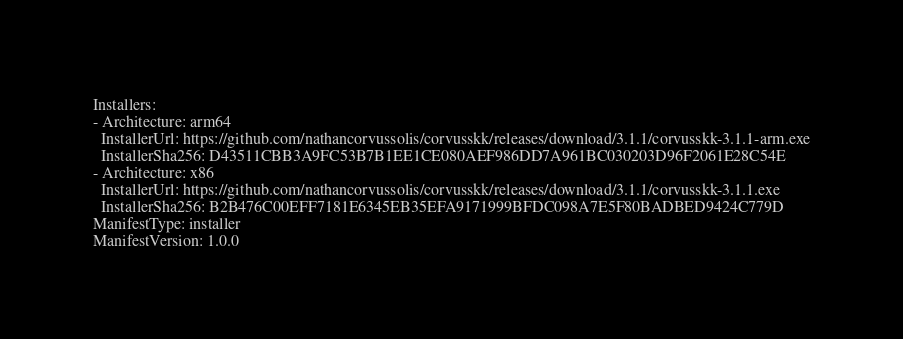Convert code to text. <code><loc_0><loc_0><loc_500><loc_500><_YAML_>Installers:
- Architecture: arm64
  InstallerUrl: https://github.com/nathancorvussolis/corvusskk/releases/download/3.1.1/corvusskk-3.1.1-arm.exe
  InstallerSha256: D43511CBB3A9FC53B7B1EE1CE080AEF986DD7A961BC030203D96F2061E28C54E
- Architecture: x86
  InstallerUrl: https://github.com/nathancorvussolis/corvusskk/releases/download/3.1.1/corvusskk-3.1.1.exe
  InstallerSha256: B2B476C00EFF7181E6345EB35EFA9171999BFDC098A7E5F80BADBED9424C779D
ManifestType: installer
ManifestVersion: 1.0.0
</code> 